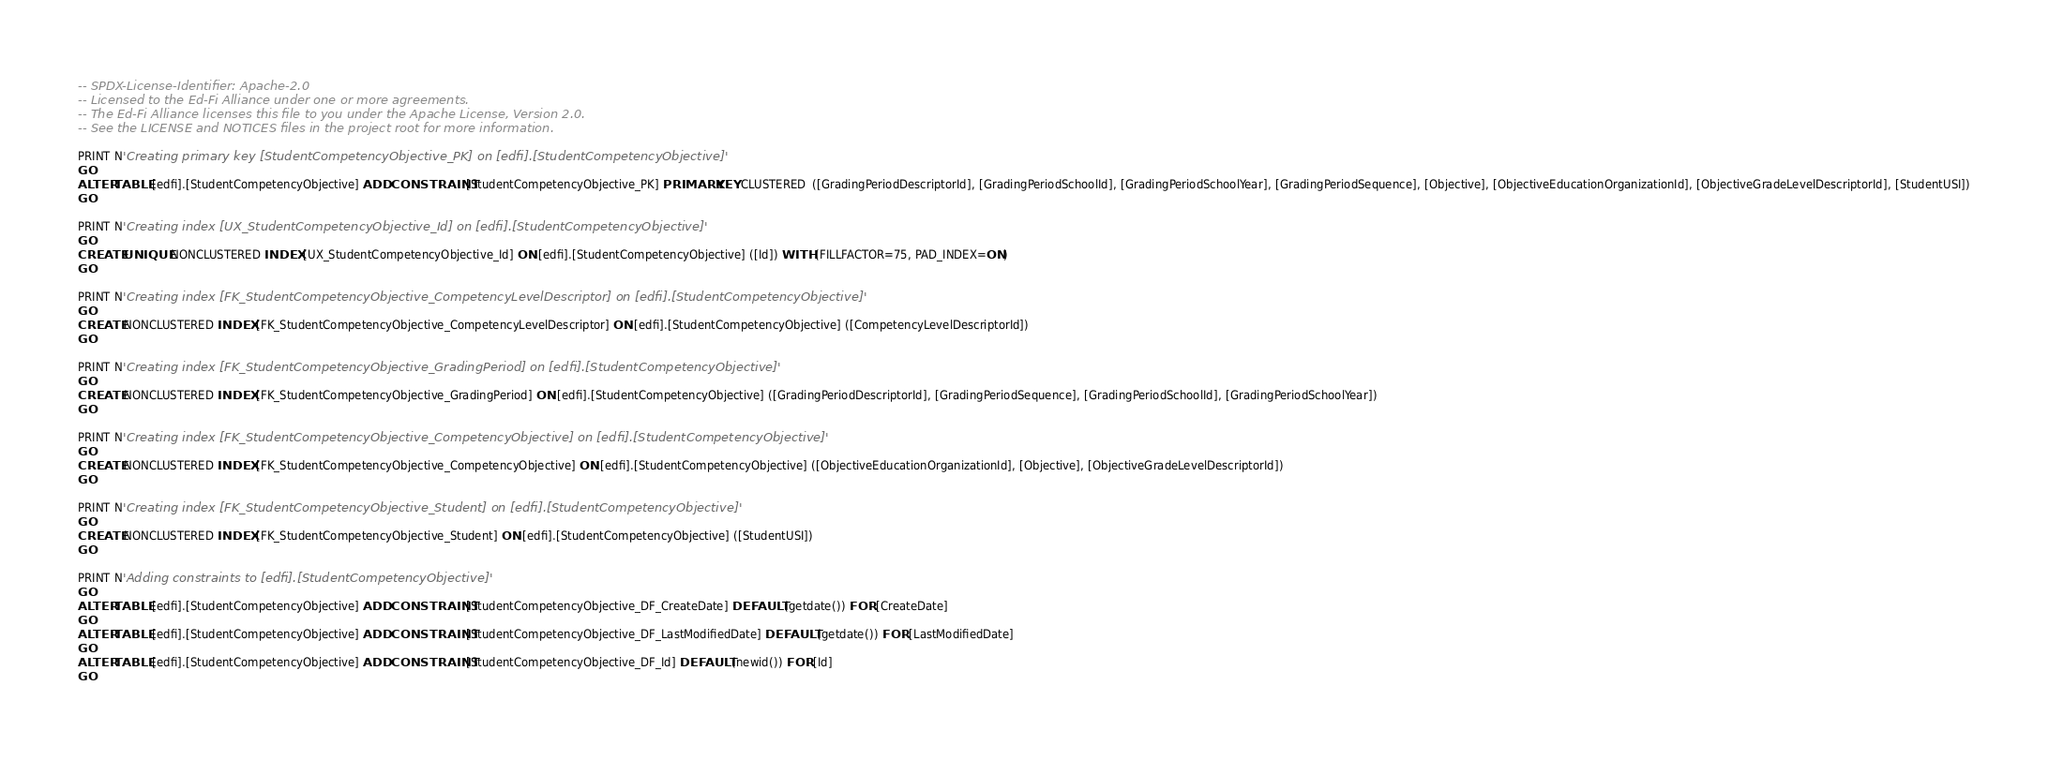Convert code to text. <code><loc_0><loc_0><loc_500><loc_500><_SQL_>-- SPDX-License-Identifier: Apache-2.0
-- Licensed to the Ed-Fi Alliance under one or more agreements.
-- The Ed-Fi Alliance licenses this file to you under the Apache License, Version 2.0.
-- See the LICENSE and NOTICES files in the project root for more information.

PRINT N'Creating primary key [StudentCompetencyObjective_PK] on [edfi].[StudentCompetencyObjective]'
GO
ALTER TABLE [edfi].[StudentCompetencyObjective] ADD CONSTRAINT [StudentCompetencyObjective_PK] PRIMARY KEY CLUSTERED  ([GradingPeriodDescriptorId], [GradingPeriodSchoolId], [GradingPeriodSchoolYear], [GradingPeriodSequence], [Objective], [ObjectiveEducationOrganizationId], [ObjectiveGradeLevelDescriptorId], [StudentUSI])
GO

PRINT N'Creating index [UX_StudentCompetencyObjective_Id] on [edfi].[StudentCompetencyObjective]'
GO
CREATE UNIQUE NONCLUSTERED INDEX [UX_StudentCompetencyObjective_Id] ON [edfi].[StudentCompetencyObjective] ([Id]) WITH (FILLFACTOR=75, PAD_INDEX=ON)
GO

PRINT N'Creating index [FK_StudentCompetencyObjective_CompetencyLevelDescriptor] on [edfi].[StudentCompetencyObjective]'
GO
CREATE NONCLUSTERED INDEX [FK_StudentCompetencyObjective_CompetencyLevelDescriptor] ON [edfi].[StudentCompetencyObjective] ([CompetencyLevelDescriptorId])
GO

PRINT N'Creating index [FK_StudentCompetencyObjective_GradingPeriod] on [edfi].[StudentCompetencyObjective]'
GO
CREATE NONCLUSTERED INDEX [FK_StudentCompetencyObjective_GradingPeriod] ON [edfi].[StudentCompetencyObjective] ([GradingPeriodDescriptorId], [GradingPeriodSequence], [GradingPeriodSchoolId], [GradingPeriodSchoolYear])
GO

PRINT N'Creating index [FK_StudentCompetencyObjective_CompetencyObjective] on [edfi].[StudentCompetencyObjective]'
GO
CREATE NONCLUSTERED INDEX [FK_StudentCompetencyObjective_CompetencyObjective] ON [edfi].[StudentCompetencyObjective] ([ObjectiveEducationOrganizationId], [Objective], [ObjectiveGradeLevelDescriptorId])
GO

PRINT N'Creating index [FK_StudentCompetencyObjective_Student] on [edfi].[StudentCompetencyObjective]'
GO
CREATE NONCLUSTERED INDEX [FK_StudentCompetencyObjective_Student] ON [edfi].[StudentCompetencyObjective] ([StudentUSI])
GO

PRINT N'Adding constraints to [edfi].[StudentCompetencyObjective]'
GO
ALTER TABLE [edfi].[StudentCompetencyObjective] ADD CONSTRAINT [StudentCompetencyObjective_DF_CreateDate] DEFAULT (getdate()) FOR [CreateDate]
GO
ALTER TABLE [edfi].[StudentCompetencyObjective] ADD CONSTRAINT [StudentCompetencyObjective_DF_LastModifiedDate] DEFAULT (getdate()) FOR [LastModifiedDate]
GO
ALTER TABLE [edfi].[StudentCompetencyObjective] ADD CONSTRAINT [StudentCompetencyObjective_DF_Id] DEFAULT (newid()) FOR [Id]
GO
</code> 